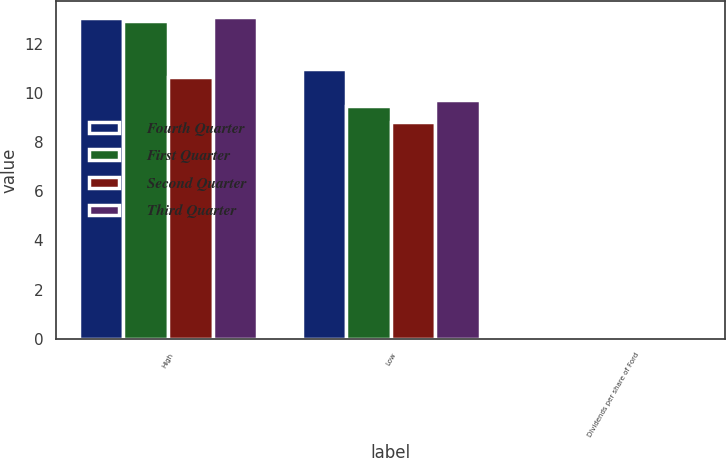Convert chart to OTSL. <chart><loc_0><loc_0><loc_500><loc_500><stacked_bar_chart><ecel><fcel>High<fcel>Low<fcel>Dividends per share of Ford<nl><fcel>Fourth Quarter<fcel>13.05<fcel>10.99<fcel>0.05<nl><fcel>First Quarter<fcel>12.95<fcel>9.46<fcel>0.05<nl><fcel>Second Quarter<fcel>10.66<fcel>8.82<fcel>0.05<nl><fcel>Third Quarter<fcel>13.08<fcel>9.71<fcel>0.05<nl></chart> 